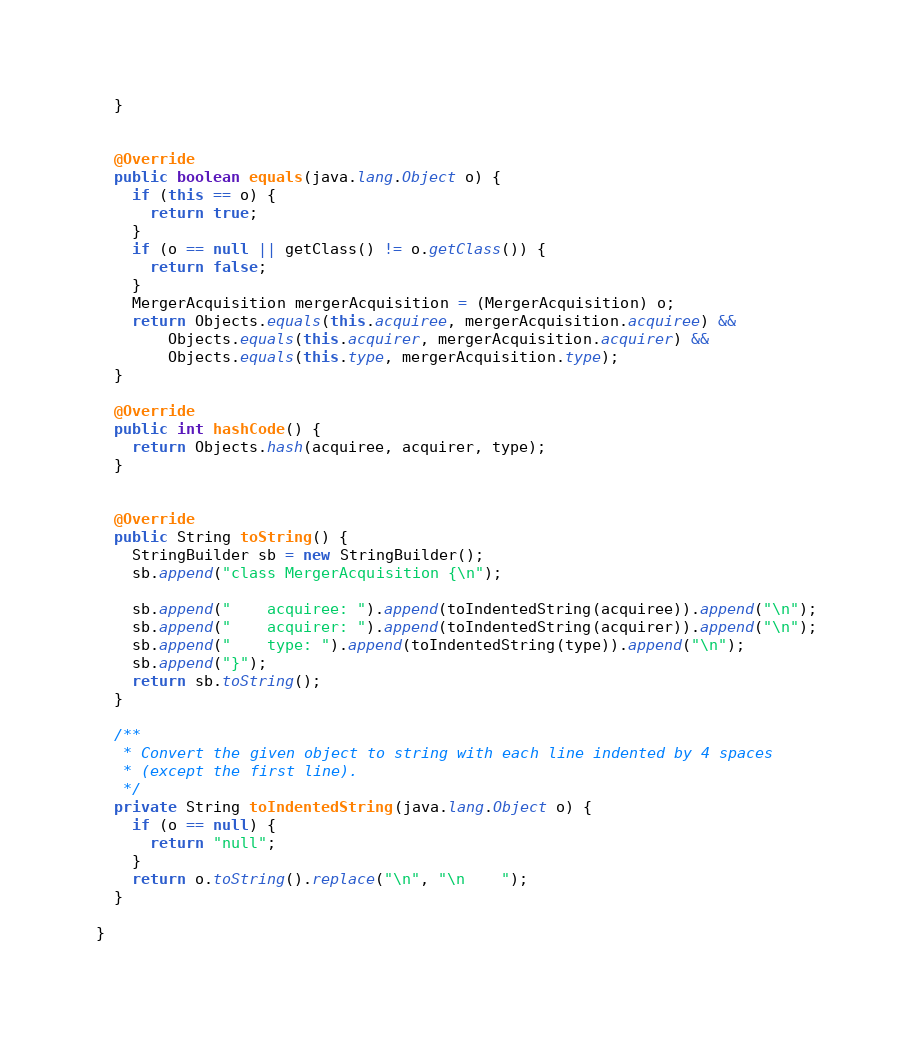Convert code to text. <code><loc_0><loc_0><loc_500><loc_500><_Java_>  }


  @Override
  public boolean equals(java.lang.Object o) {
    if (this == o) {
      return true;
    }
    if (o == null || getClass() != o.getClass()) {
      return false;
    }
    MergerAcquisition mergerAcquisition = (MergerAcquisition) o;
    return Objects.equals(this.acquiree, mergerAcquisition.acquiree) &&
        Objects.equals(this.acquirer, mergerAcquisition.acquirer) &&
        Objects.equals(this.type, mergerAcquisition.type);
  }

  @Override
  public int hashCode() {
    return Objects.hash(acquiree, acquirer, type);
  }


  @Override
  public String toString() {
    StringBuilder sb = new StringBuilder();
    sb.append("class MergerAcquisition {\n");
    
    sb.append("    acquiree: ").append(toIndentedString(acquiree)).append("\n");
    sb.append("    acquirer: ").append(toIndentedString(acquirer)).append("\n");
    sb.append("    type: ").append(toIndentedString(type)).append("\n");
    sb.append("}");
    return sb.toString();
  }

  /**
   * Convert the given object to string with each line indented by 4 spaces
   * (except the first line).
   */
  private String toIndentedString(java.lang.Object o) {
    if (o == null) {
      return "null";
    }
    return o.toString().replace("\n", "\n    ");
  }

}

</code> 